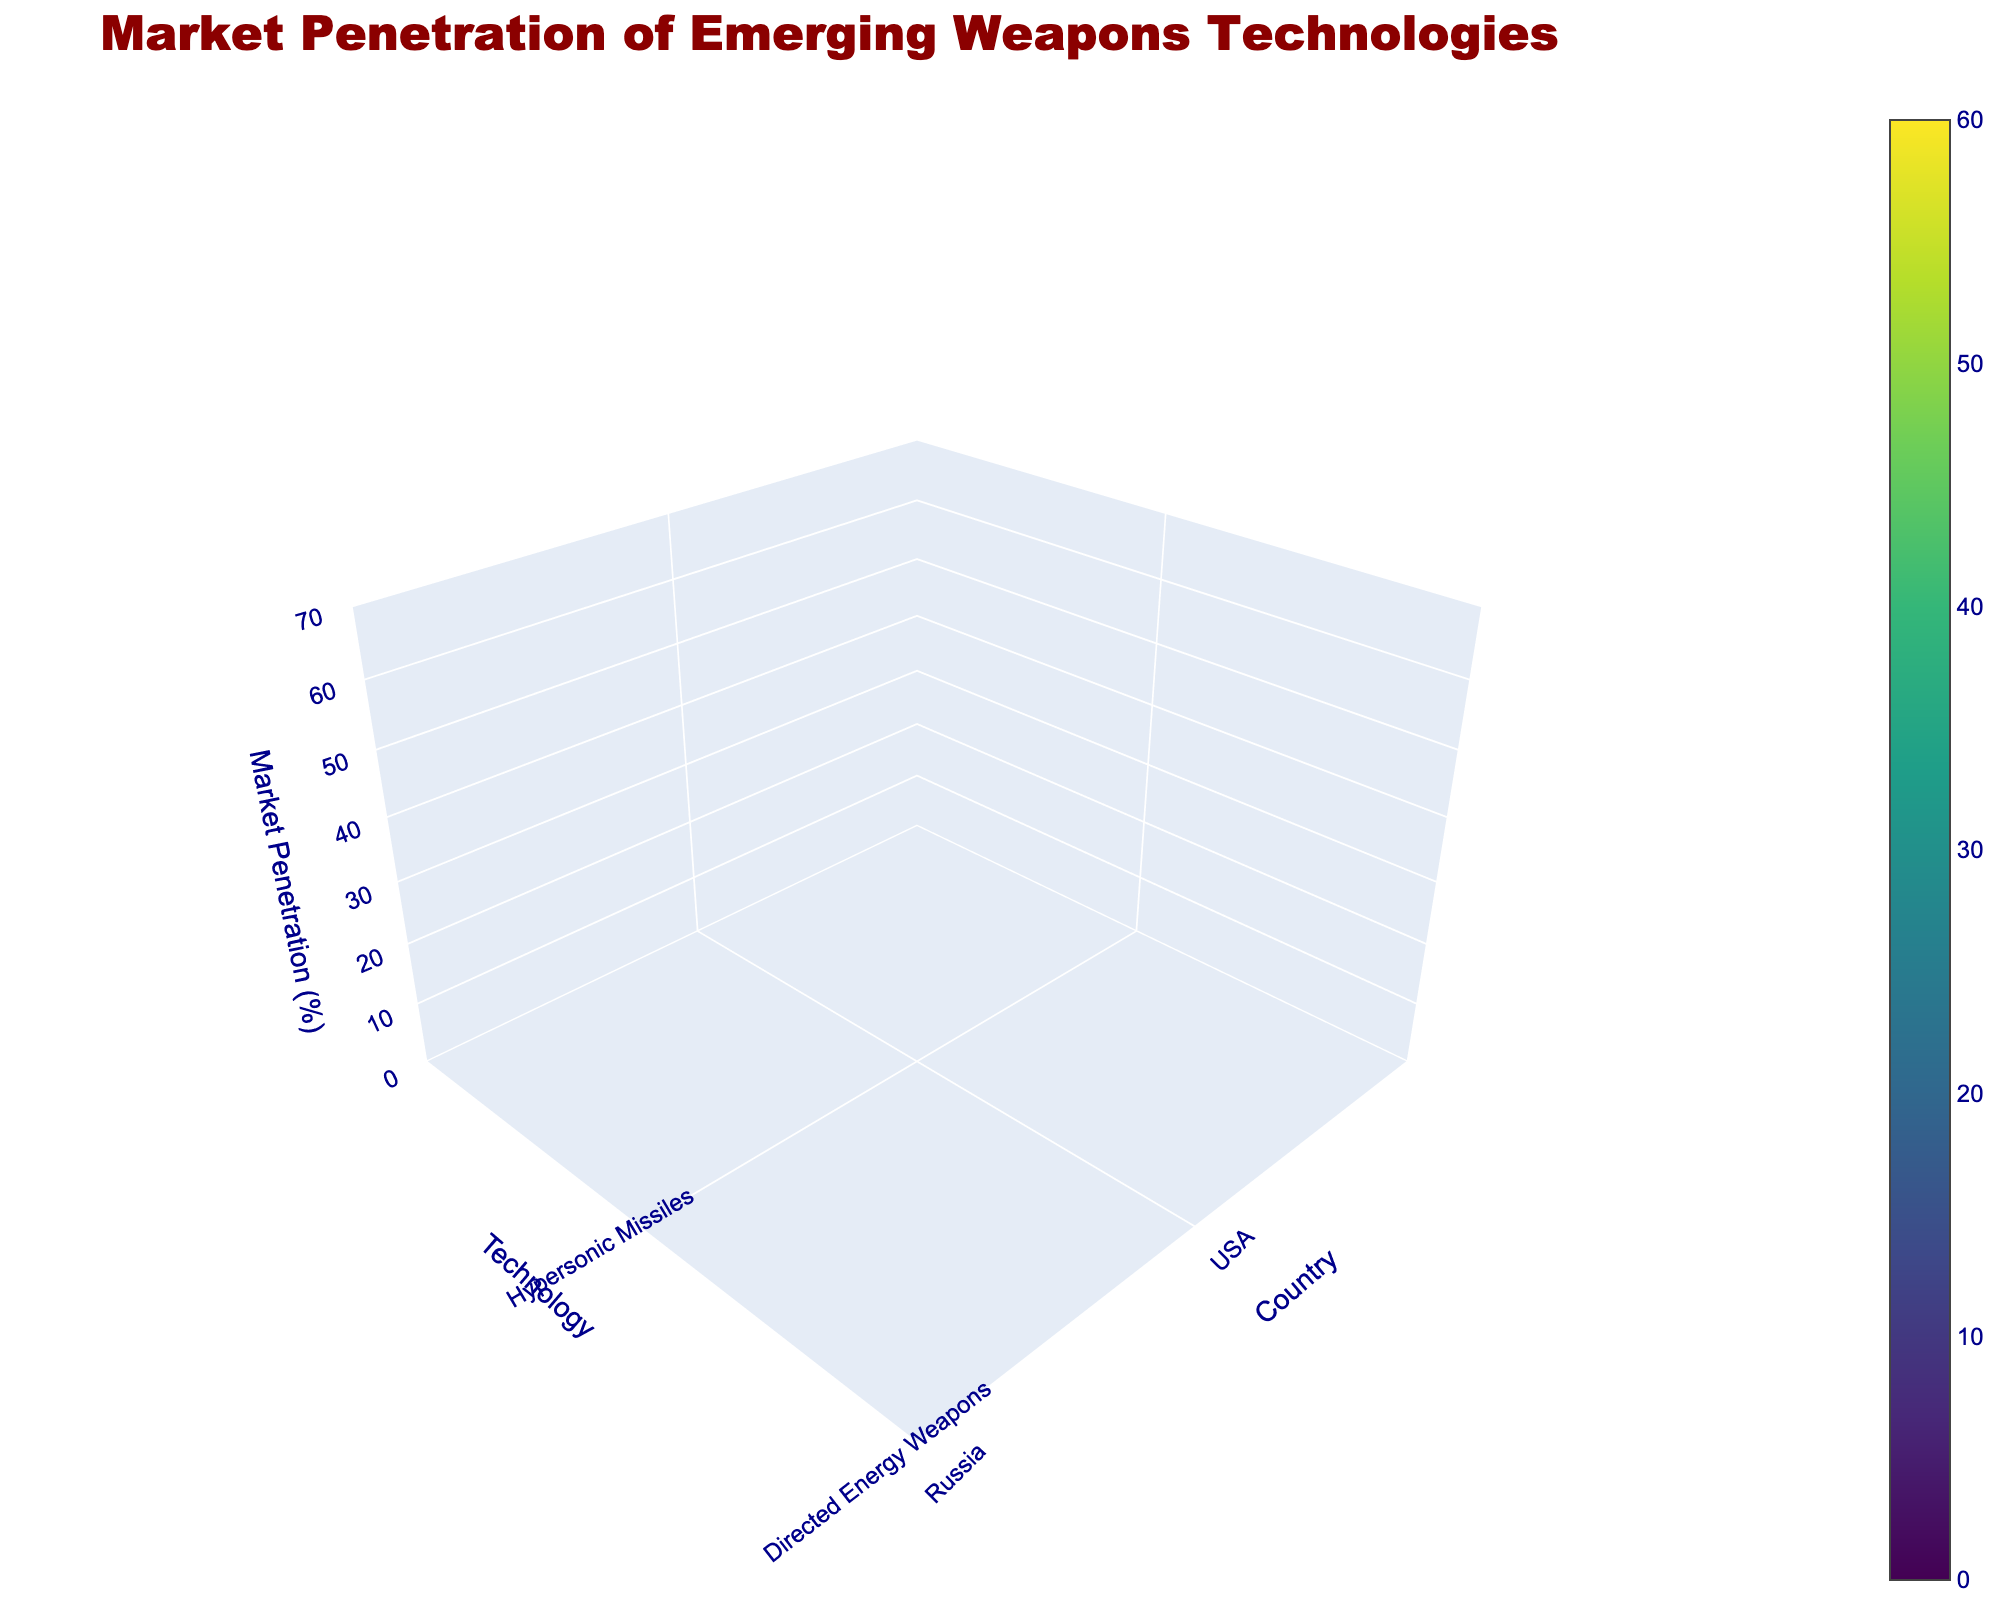What's the title of the figure? The title is located at the top of the figure and it provides a description of what the plot represents.
Answer: Market Penetration of Emerging Weapons Technologies Which country has the highest market penetration for Hypersonic Missiles? By examining the z-axis values and the corresponding country labels along the x-axis, the country with the highest z value for Hypersonic Missiles is identified.
Answer: Russia How many technologies are shown in the figure? The number of unique labels on the y-axis represents the number of different technologies shown in the figure.
Answer: 4 Which technology does Israel have the highest market penetration in? By looking at the values corresponding to Israel on the x-axis and comparing them across different technologies on the y-axis, we can determine which technology has the highest value for Israel.
Answer: Directed Energy Weapons What is the difference in market penetration between USA and China for AI-powered Autonomous Weapons? First, identify the market penetration values for AI-powered Autonomous Weapons for both countries from the plot. Then, compute the difference between the two values. 55 - 50 = 5.
Answer: 5% Which country has the lowest market penetration in Quantum Radar Systems, and what is its value? By finding the smallest value on the z-axis for Quantum Radar Systems and identifying the corresponding country on the x-axis, the country with the lowest penetration and its value are determined.
Answer: India, 10% On average, how well is Hypersonic Missiles technology penetrating the market across all countries? Collect the market penetration values for Hypersonic Missiles from all countries, sum them up, and divide by the number of countries. (45 + 60 + 55 + 20 + 30)/5 = 42
Answer: 42% Which technology has the most consistent market penetration across different countries? Evaluate the variation or range in market penetration values for each technology across different countries and identify the one with the smallest variation.
Answer: Quantum Radar Systems What is the average market penetration value for all technologies in the USA? Extract all market penetration values for each technology in the USA from the plot and compute their average. (45 + 35 + 50 + 30)/4 = 40
Answer: 40% When comparing Directed Energy Weapons and AI-powered Autonomous Weapons, which one has higher market penetration in Israel? Examine the market penetration values for Directed Energy Weapons and AI-powered Autonomous Weapons specifically for Israel and compare the two.
Answer: AI-powered Autonomous Weapons 